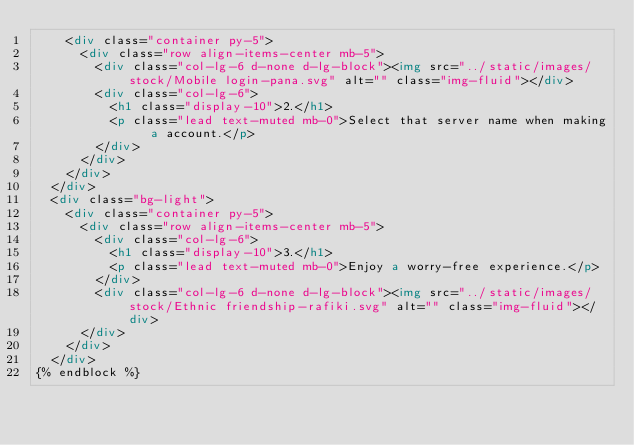<code> <loc_0><loc_0><loc_500><loc_500><_HTML_>    <div class="container py-5">
      <div class="row align-items-center mb-5">
        <div class="col-lg-6 d-none d-lg-block"><img src="../static/images/stock/Mobile login-pana.svg" alt="" class="img-fluid"></div>
        <div class="col-lg-6">
          <h1 class="display-10">2.</h1>
          <p class="lead text-muted mb-0">Select that server name when making a account.</p>
        </div>
      </div>
    </div>
  </div>
  <div class="bg-light">
    <div class="container py-5">
      <div class="row align-items-center mb-5">
        <div class="col-lg-6">
          <h1 class="display-10">3.</h1>
          <p class="lead text-muted mb-0">Enjoy a worry-free experience.</p>
        </div>
        <div class="col-lg-6 d-none d-lg-block"><img src="../static/images/stock/Ethnic friendship-rafiki.svg" alt="" class="img-fluid"></div>
      </div>
    </div>
  </div>
{% endblock %}
</code> 